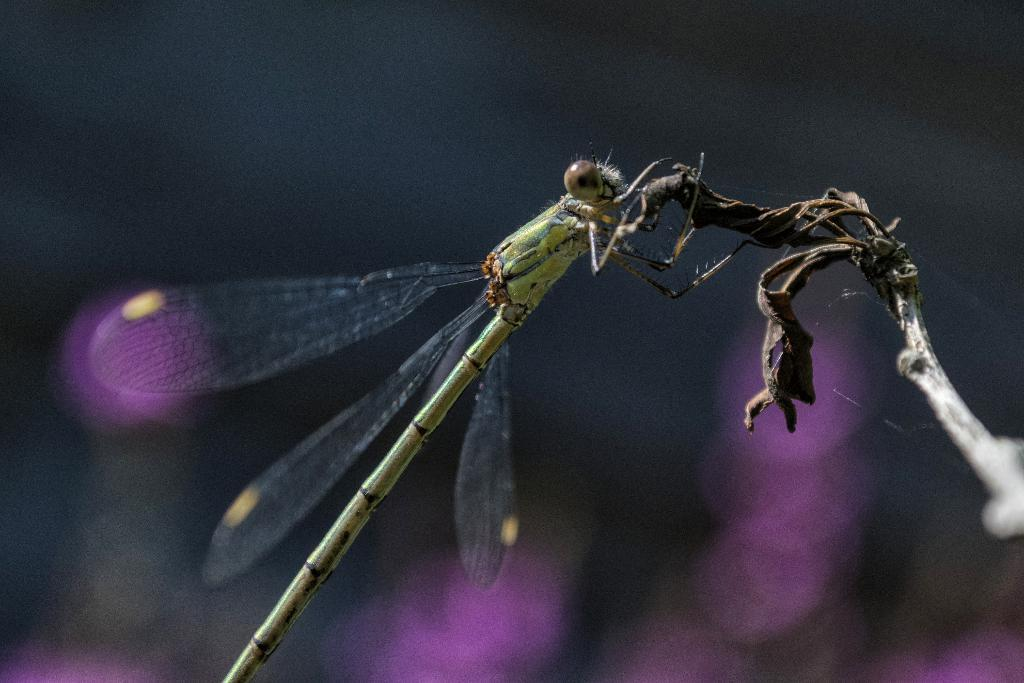What insect is present in the image? There is a dragonfly in the image. Where is the dragonfly located on the stem? The dragonfly is on a stem in the image. How is the dragonfly positioned in the image? The dragonfly is in the center of the image. What type of sweater is the dragonfly wearing in the image? There is no sweater present in the image, as dragonflies do not wear clothing. 